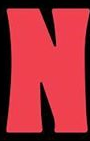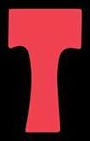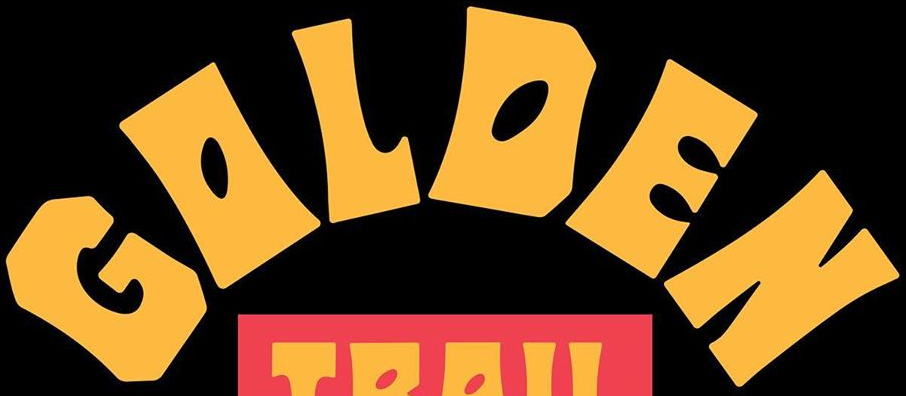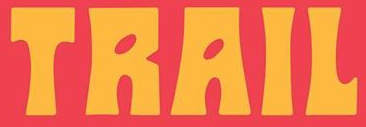What text is displayed in these images sequentially, separated by a semicolon? N; T; GOLDEN; TRAIL 